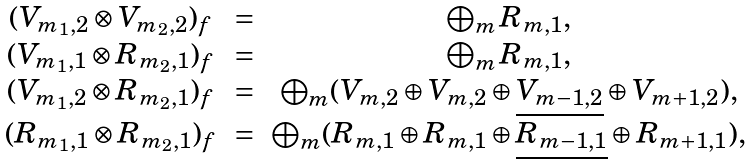Convert formula to latex. <formula><loc_0><loc_0><loc_500><loc_500>\begin{array} { c c c } ( V _ { m _ { 1 } , 2 } \otimes V _ { m _ { 2 } , 2 } ) _ { f } & = & \bigoplus _ { m } R _ { m , 1 } , \\ ( V _ { m _ { 1 } , 1 } \otimes R _ { m _ { 2 } , 1 } ) _ { f } & = & \bigoplus _ { m } R _ { m , 1 } , \\ ( V _ { m _ { 1 } , 2 } \otimes R _ { m _ { 2 } , 1 } ) _ { f } & = & \bigoplus _ { m } ( V _ { m , 2 } \oplus V _ { m , 2 } \oplus \underline { V _ { m - 1 , 2 } } \oplus V _ { m + 1 , 2 } ) , \\ ( R _ { m _ { 1 } , 1 } \otimes R _ { m _ { 2 } , 1 } ) _ { f } & = & \bigoplus _ { m } ( R _ { m , 1 } \oplus R _ { m , 1 } \oplus \underline { R _ { m - 1 , 1 } } \oplus R _ { m + 1 , 1 } ) , \end{array}</formula> 